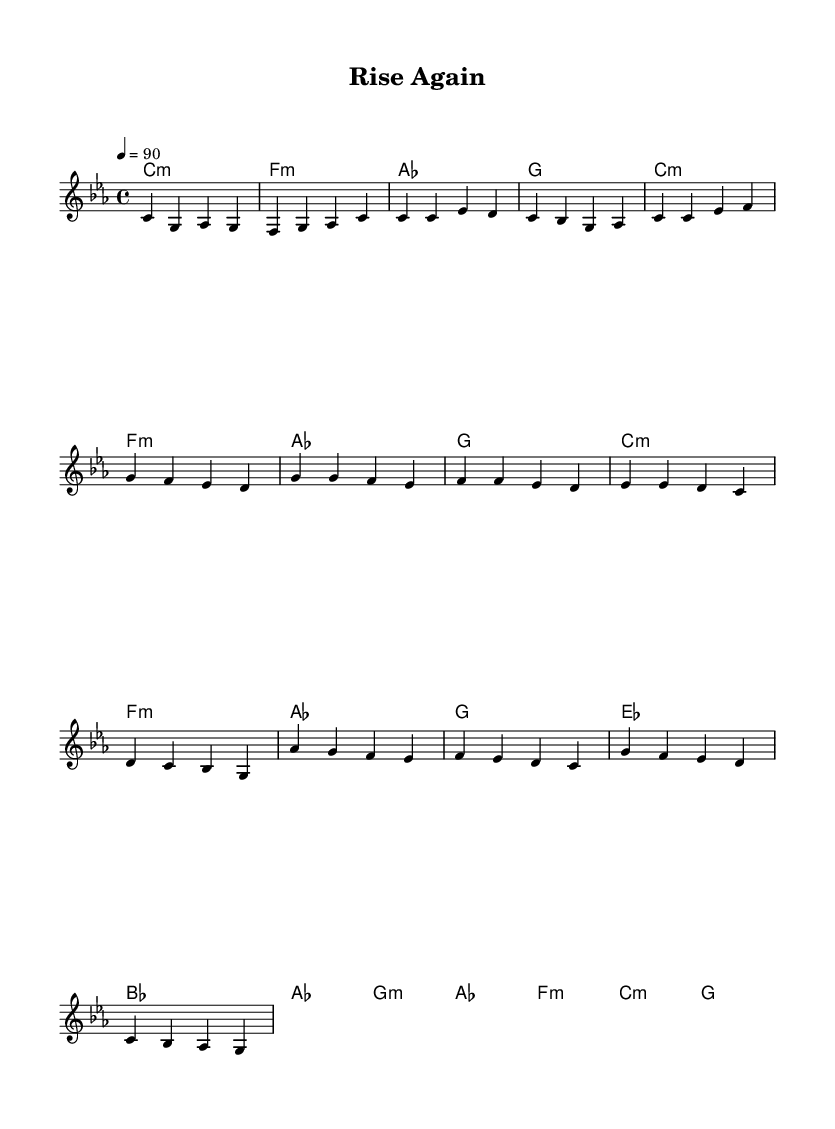What is the key signature of this music? The key signature is C minor, which has three flats: B flat, E flat, and A flat.
Answer: C minor What is the time signature of this music? The time signature is indicated by the numbers at the beginning of the score, which is 4 over 4. This means there are four beats in a measure and the quarter note gets one beat.
Answer: 4/4 What is the tempo marking at the beginning? The tempo marking indicates that the piece should be played at a speed of 90 beats per minute (BPM). This is specified as "4 = 90" in the tempo area of the score.
Answer: 90 How many measures are in the chorus section? The chorus section consists of four measures, as can be seen by counting the group divisions in that section of the score.
Answer: 4 What is the first chord in the music? The first chord in the score is indicated in the harmonies section and is labeled as C minor (c:m).
Answer: C minor Which section follows the verse? The next section that follows the verse is the chorus, which is indicated in the arrangement of the score. This can be confirmed by looking at the structure of the song where the verse leads into the chorus.
Answer: Chorus How does the bridge begin musically? The bridge begins with an A flat major chord (as), as observed in the chord section of the bridge. This shows the transition point in the song's structure leading from the chorus.
Answer: A flat 